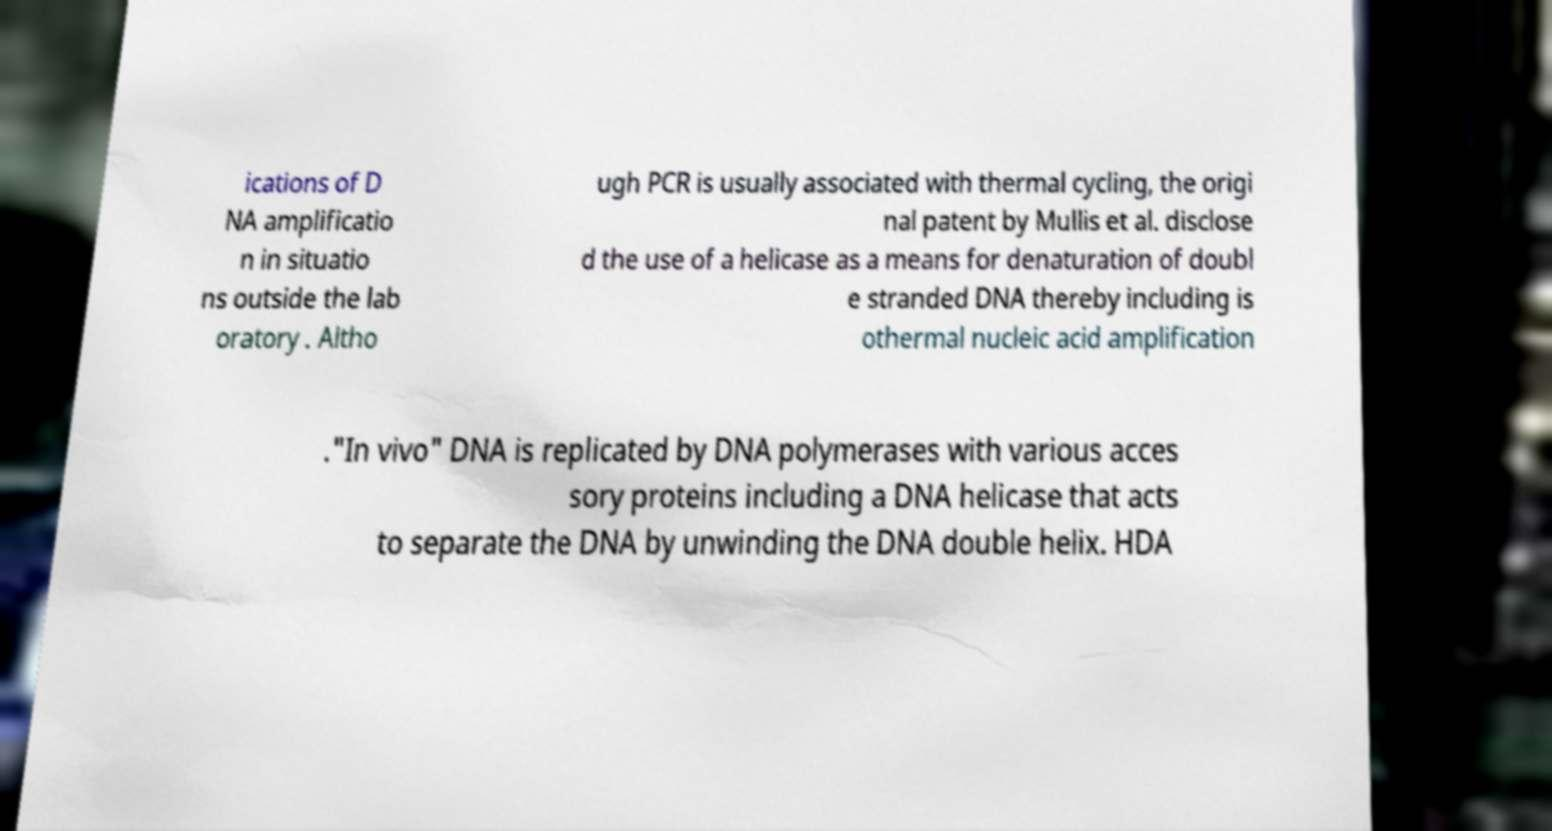Please read and relay the text visible in this image. What does it say? ications of D NA amplificatio n in situatio ns outside the lab oratory . Altho ugh PCR is usually associated with thermal cycling, the origi nal patent by Mullis et al. disclose d the use of a helicase as a means for denaturation of doubl e stranded DNA thereby including is othermal nucleic acid amplification ."In vivo" DNA is replicated by DNA polymerases with various acces sory proteins including a DNA helicase that acts to separate the DNA by unwinding the DNA double helix. HDA 